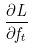<formula> <loc_0><loc_0><loc_500><loc_500>\frac { \partial L } { \partial f _ { t } }</formula> 